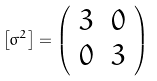<formula> <loc_0><loc_0><loc_500><loc_500>\left [ \sigma ^ { 2 } \right ] = \left ( \begin{array} { c c } 3 & 0 \\ 0 & 3 \end{array} \right )</formula> 